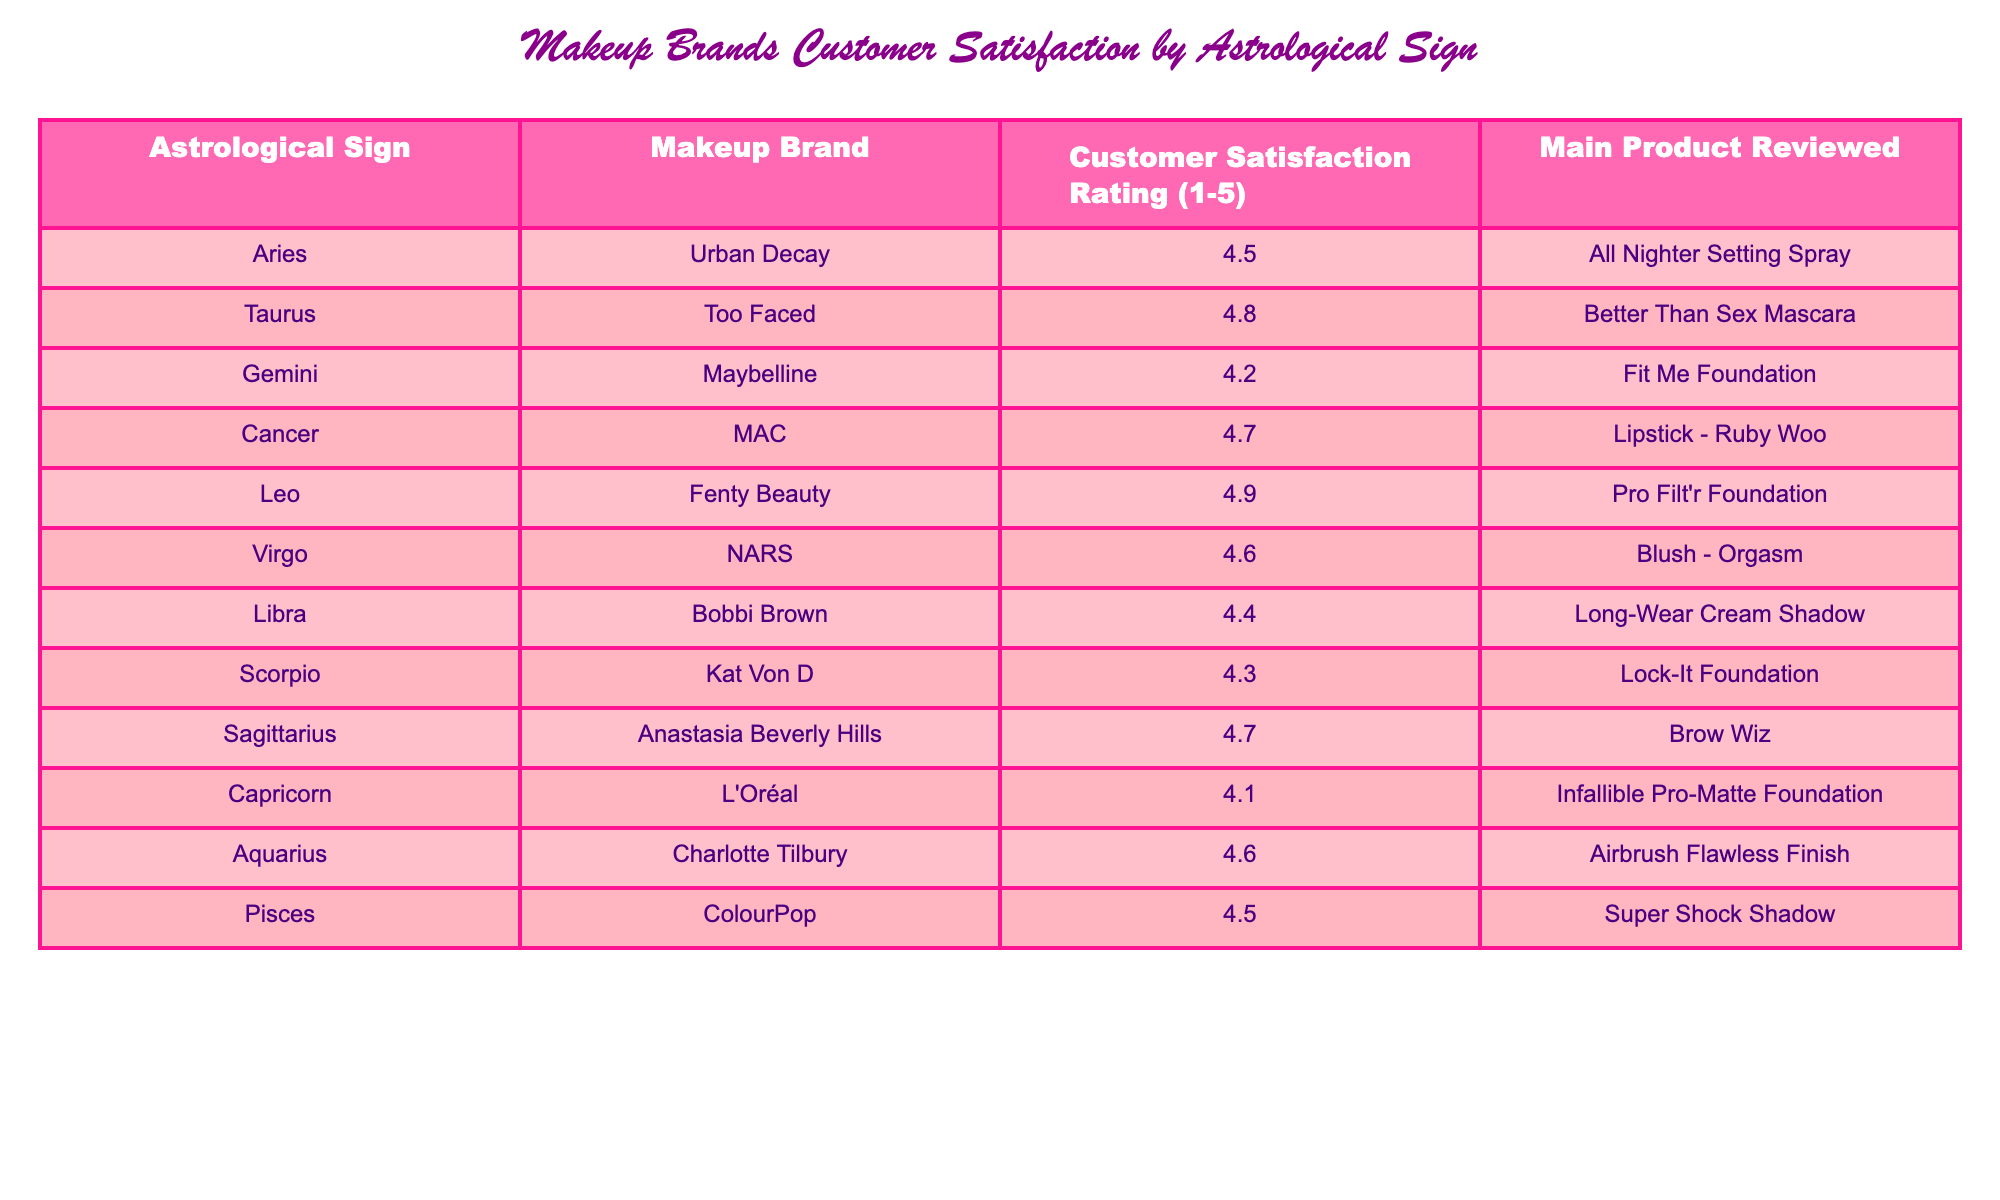What is the customer satisfaction rating for Fenty Beauty? The rating for Fenty Beauty, which is under the astrological sign Leo, can be directly retrieved from the table: 4.9.
Answer: 4.9 Which makeup brand has the highest satisfaction rating? The table shows that Fenty Beauty has the highest satisfaction rating of 4.9.
Answer: Fenty Beauty What is the average customer satisfaction rating for the makeup brands associated with water signs (Cancer, Scorpio, Pisces)? First, identify the ratings for the water signs: Cancer is 4.7, Scorpio is 4.3, and Pisces is 4.5. Then, sum these ratings: 4.7 + 4.3 + 4.5 = 13.5. Finally, divide by the number of water signs (3): 13.5 / 3 = 4.5.
Answer: 4.5 Does MAC have a customer satisfaction rating of 5 or higher? According to the table, MAC's rating is 4.7, which is less than 5, so the answer is no.
Answer: No Which astrological sign has the third highest customer satisfaction rating? The sorted ratings in descending order are: Fenty Beauty (4.9), Taurus (4.8), and Cancer (4.7). Thus, Cancer, which corresponds to Cancer's row, has the third highest rating.
Answer: Cancer Is there a makeup brand under the sign of Capricorn that has a satisfaction rating of 4 or higher? The table shows that L'Oréal, the brand associated with Capricorn, has a rating of 4.1, which is greater than 4. Therefore, the answer is yes.
Answer: Yes What are the satisfaction ratings of the brands for air signs (Gemini, Libra, Aquarius)? The ratings for the air signs can be found in the table: Gemini is 4.2, Libra is 4.4, and Aquarius is 4.6. Thus, those are the satisfaction ratings for the air signs respectively.
Answer: 4.2, 4.4, 4.6 What is the difference in satisfaction ratings between the highest and the lowest rated brands? The highest rating is from Fenty Beauty at 4.9, and the lowest is L'Oréal at 4.1. To find the difference, subtract the lowest from the highest: 4.9 - 4.1 = 0.8.
Answer: 0.8 